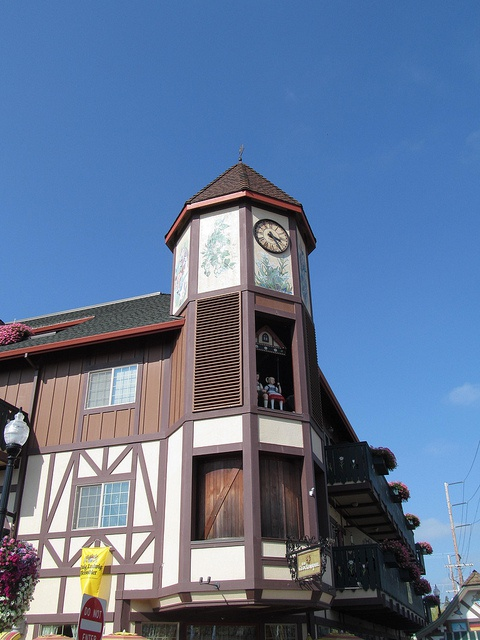Describe the objects in this image and their specific colors. I can see a clock in gray, darkgray, black, and tan tones in this image. 